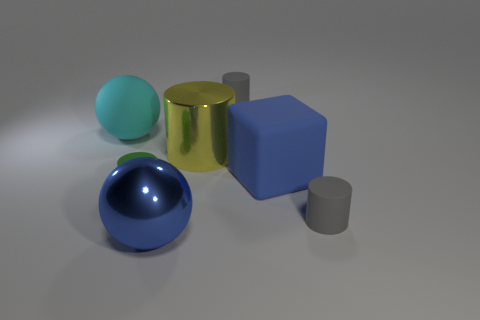What number of things are either big spheres that are in front of the tiny green rubber cylinder or big cyan things?
Keep it short and to the point. 2. The other large thing that is the same shape as the cyan rubber thing is what color?
Keep it short and to the point. Blue. Are there any other things that have the same color as the large shiny cylinder?
Keep it short and to the point. No. There is a blue thing in front of the big blue block; what is its size?
Offer a terse response. Large. Does the large rubber sphere have the same color as the large sphere in front of the matte block?
Your response must be concise. No. How many other objects are there of the same material as the big yellow cylinder?
Ensure brevity in your answer.  1. Are there more yellow cylinders than brown matte blocks?
Offer a terse response. Yes. Is the color of the cylinder that is on the right side of the big blue rubber object the same as the rubber ball?
Your answer should be very brief. No. The shiny sphere is what color?
Give a very brief answer. Blue. Is there a big metallic thing on the right side of the gray cylinder behind the large blue matte object?
Your answer should be compact. No. 